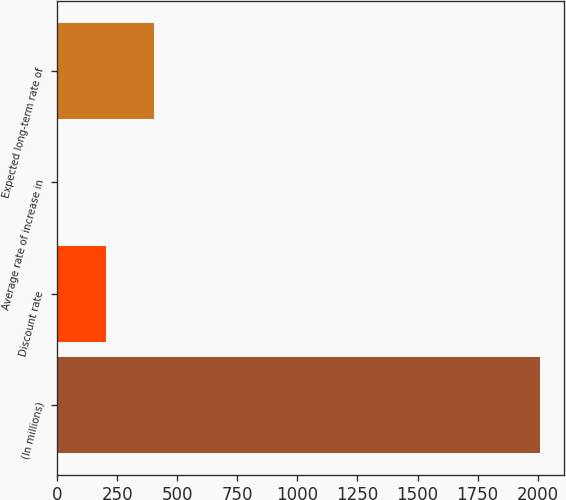<chart> <loc_0><loc_0><loc_500><loc_500><bar_chart><fcel>(In millions)<fcel>Discount rate<fcel>Average rate of increase in<fcel>Expected long-term rate of<nl><fcel>2011<fcel>204.7<fcel>4<fcel>405.4<nl></chart> 